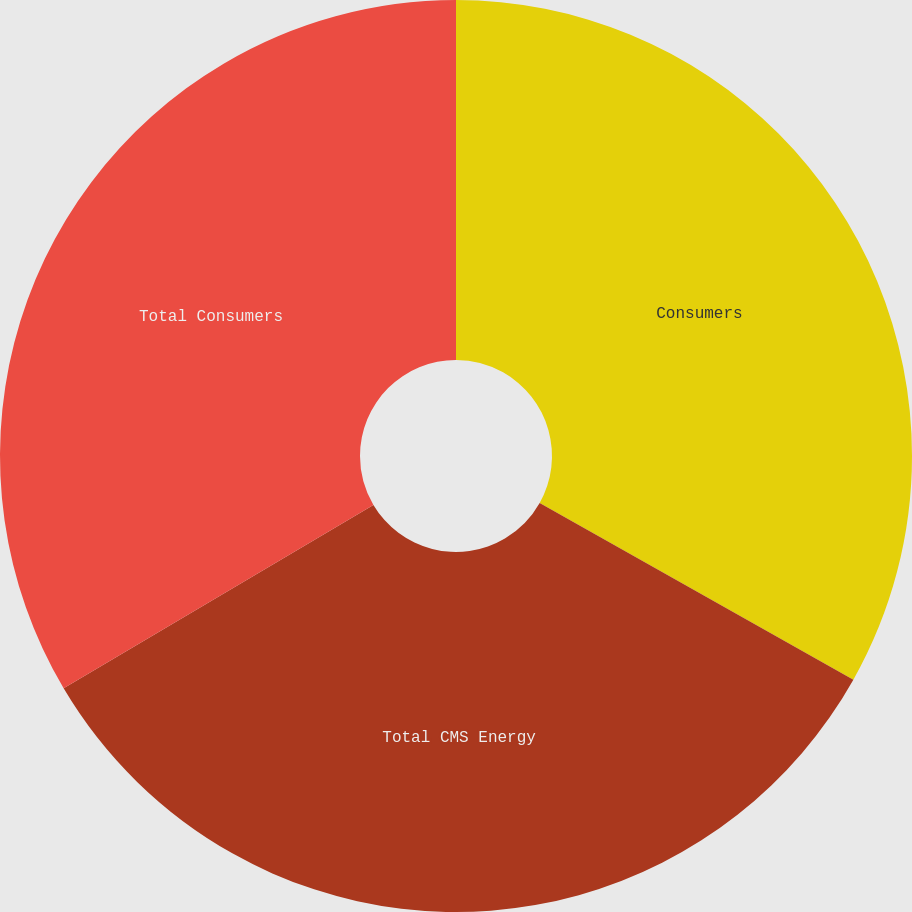Convert chart. <chart><loc_0><loc_0><loc_500><loc_500><pie_chart><fcel>Consumers<fcel>Total CMS Energy<fcel>Total Consumers<nl><fcel>33.16%<fcel>33.33%<fcel>33.51%<nl></chart> 